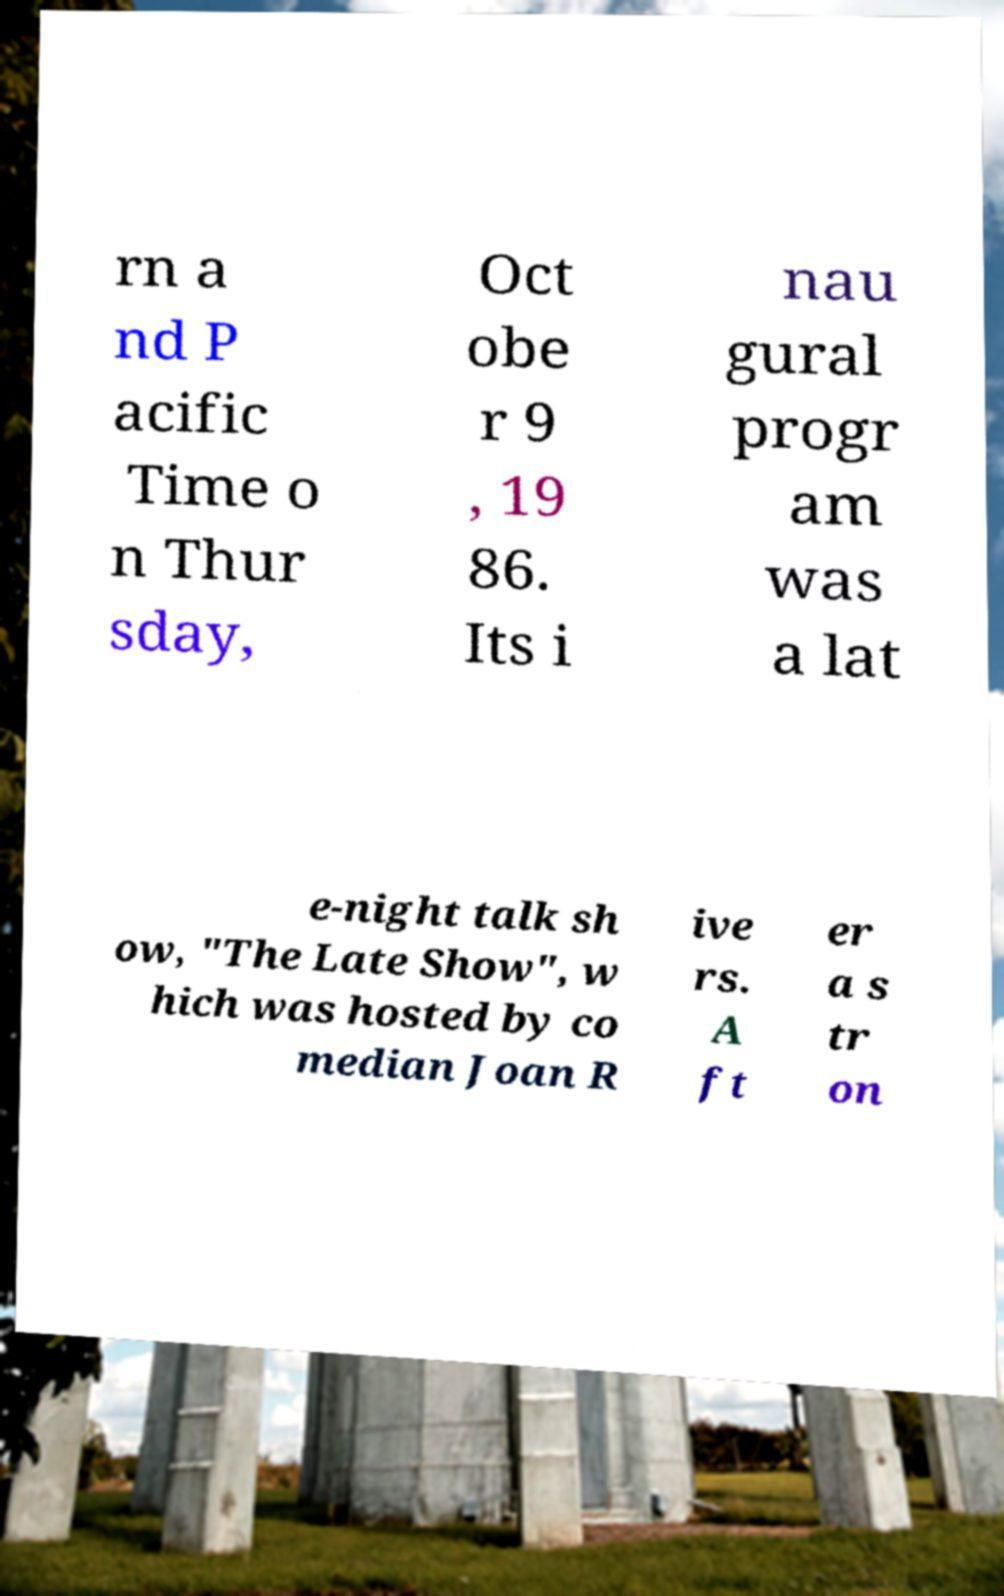There's text embedded in this image that I need extracted. Can you transcribe it verbatim? rn a nd P acific Time o n Thur sday, Oct obe r 9 , 19 86. Its i nau gural progr am was a lat e-night talk sh ow, "The Late Show", w hich was hosted by co median Joan R ive rs. A ft er a s tr on 